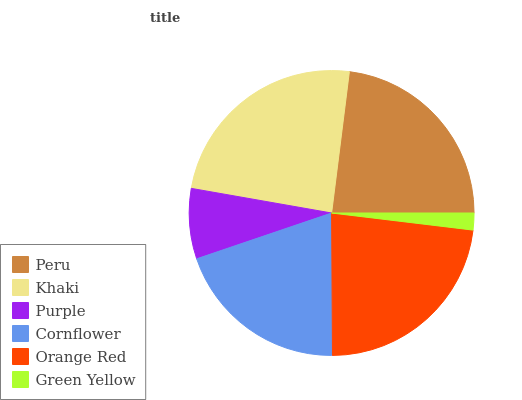Is Green Yellow the minimum?
Answer yes or no. Yes. Is Khaki the maximum?
Answer yes or no. Yes. Is Purple the minimum?
Answer yes or no. No. Is Purple the maximum?
Answer yes or no. No. Is Khaki greater than Purple?
Answer yes or no. Yes. Is Purple less than Khaki?
Answer yes or no. Yes. Is Purple greater than Khaki?
Answer yes or no. No. Is Khaki less than Purple?
Answer yes or no. No. Is Orange Red the high median?
Answer yes or no. Yes. Is Cornflower the low median?
Answer yes or no. Yes. Is Khaki the high median?
Answer yes or no. No. Is Peru the low median?
Answer yes or no. No. 